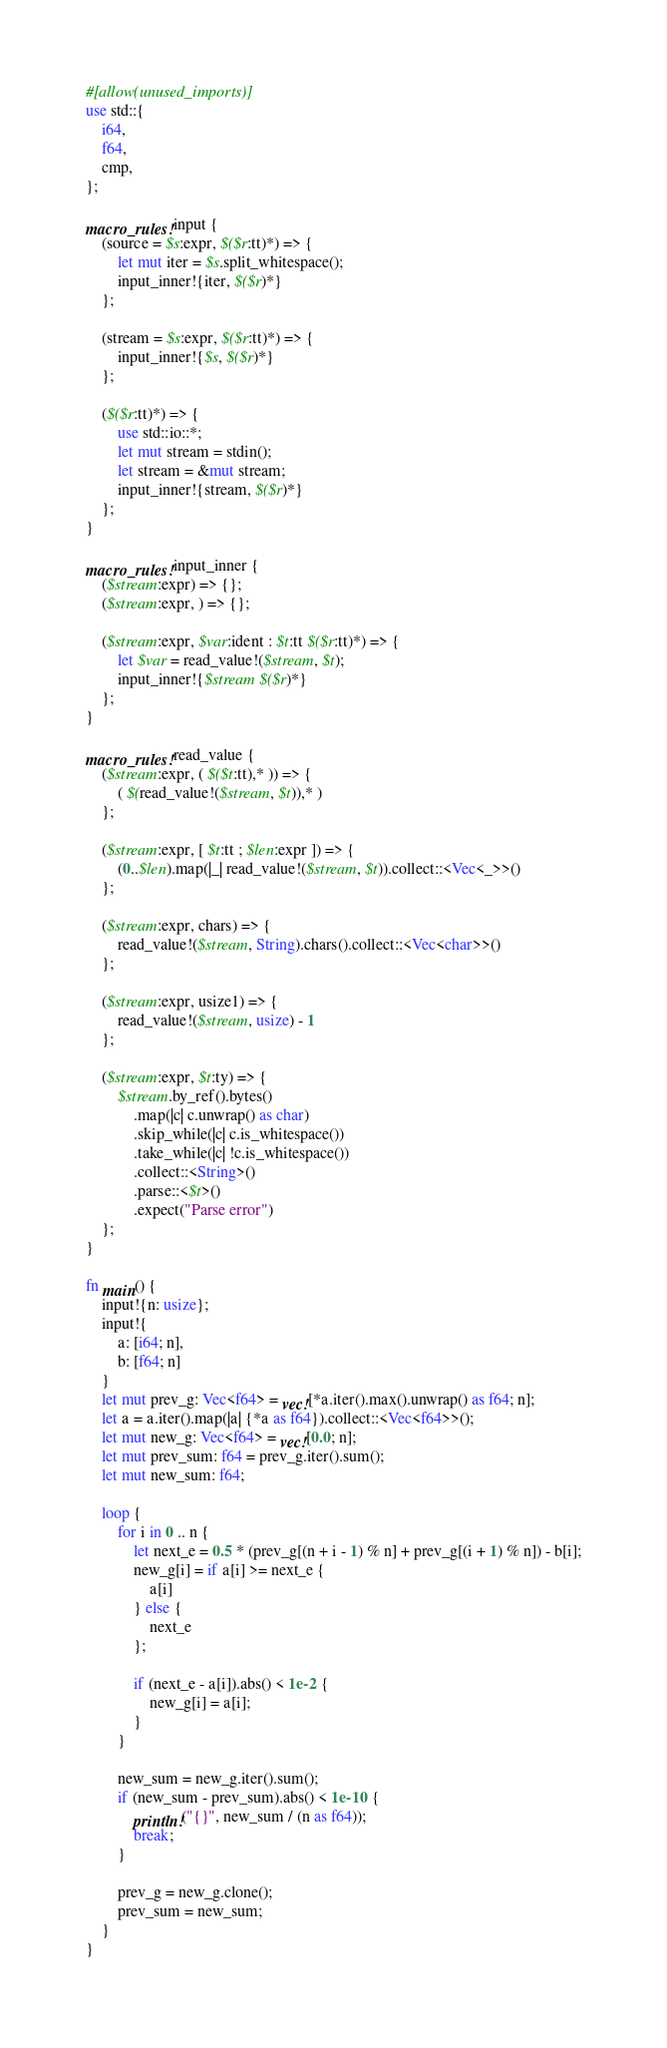<code> <loc_0><loc_0><loc_500><loc_500><_Rust_>#[allow(unused_imports)]
use std::{
    i64,
    f64,
    cmp,
};

macro_rules! input {
    (source = $s:expr, $($r:tt)*) => {
        let mut iter = $s.split_whitespace();
        input_inner!{iter, $($r)*}
    };

    (stream = $s:expr, $($r:tt)*) => {
        input_inner!{$s, $($r)*}
    };

    ($($r:tt)*) => {
        use std::io::*;
        let mut stream = stdin();
        let stream = &mut stream;
        input_inner!{stream, $($r)*}
    };
}

macro_rules! input_inner {
    ($stream:expr) => {};
    ($stream:expr, ) => {};

    ($stream:expr, $var:ident : $t:tt $($r:tt)*) => {
        let $var = read_value!($stream, $t);
        input_inner!{$stream $($r)*}
    };
}

macro_rules! read_value {
    ($stream:expr, ( $($t:tt),* )) => {
        ( $(read_value!($stream, $t)),* )
    };

    ($stream:expr, [ $t:tt ; $len:expr ]) => {
        (0..$len).map(|_| read_value!($stream, $t)).collect::<Vec<_>>()
    };

    ($stream:expr, chars) => {
        read_value!($stream, String).chars().collect::<Vec<char>>()
    };

    ($stream:expr, usize1) => {
        read_value!($stream, usize) - 1
    };

    ($stream:expr, $t:ty) => {
        $stream.by_ref().bytes()
            .map(|c| c.unwrap() as char)
            .skip_while(|c| c.is_whitespace())
            .take_while(|c| !c.is_whitespace())
            .collect::<String>()
            .parse::<$t>()
            .expect("Parse error")
    };
}

fn main() {
    input!{n: usize};
    input!{
        a: [i64; n],
        b: [f64; n]
    }
    let mut prev_g: Vec<f64> = vec![*a.iter().max().unwrap() as f64; n];
    let a = a.iter().map(|a| {*a as f64}).collect::<Vec<f64>>();
    let mut new_g: Vec<f64> = vec![0.0; n];
    let mut prev_sum: f64 = prev_g.iter().sum();
    let mut new_sum: f64;

    loop {
        for i in 0 .. n {
            let next_e = 0.5 * (prev_g[(n + i - 1) % n] + prev_g[(i + 1) % n]) - b[i];
            new_g[i] = if a[i] >= next_e {
                a[i]
            } else {
                next_e
            };

            if (next_e - a[i]).abs() < 1e-2 {
                new_g[i] = a[i];
            }
        }

        new_sum = new_g.iter().sum();
        if (new_sum - prev_sum).abs() < 1e-10 {
            println!("{}", new_sum / (n as f64));
            break;
        }

        prev_g = new_g.clone();
        prev_sum = new_sum;
    }
}</code> 